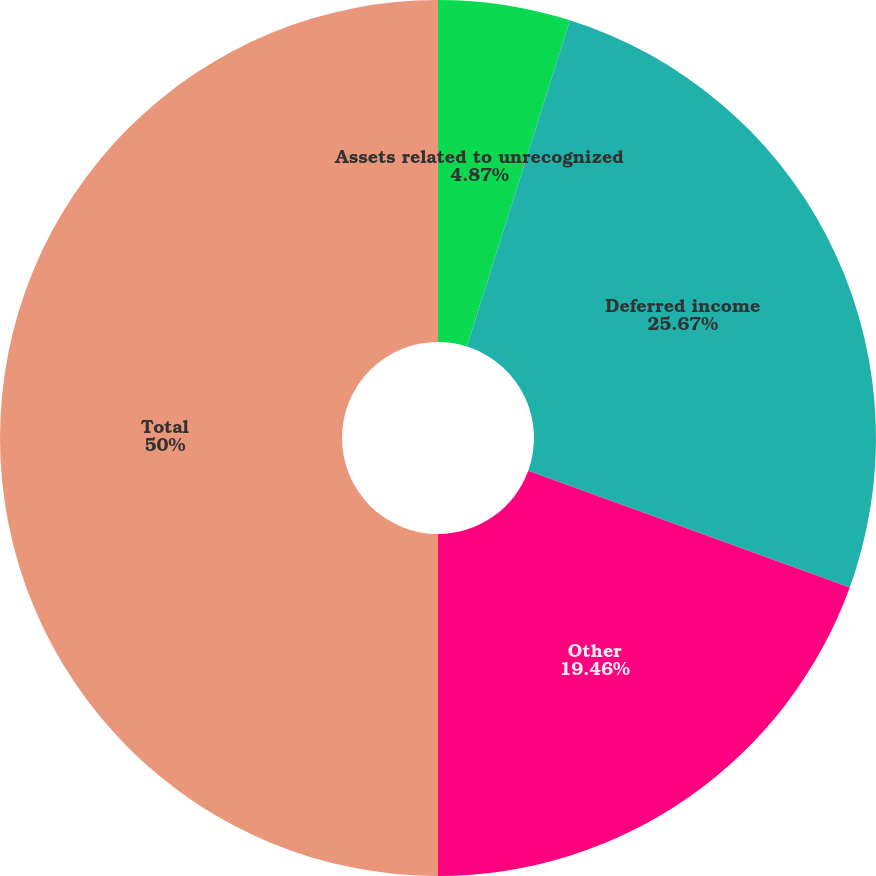Convert chart to OTSL. <chart><loc_0><loc_0><loc_500><loc_500><pie_chart><fcel>Assets related to unrecognized<fcel>Deferred income<fcel>Other<fcel>Total<nl><fcel>4.87%<fcel>25.67%<fcel>19.46%<fcel>50.0%<nl></chart> 